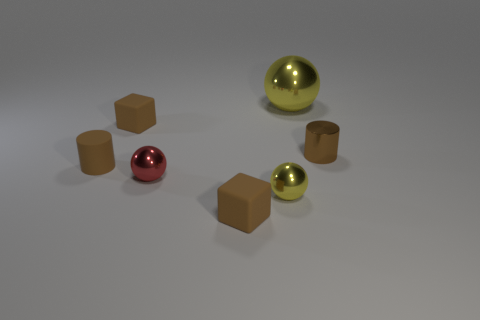Are there any tiny brown shiny objects of the same shape as the small red metallic thing?
Give a very brief answer. No. Does the large yellow shiny object have the same shape as the tiny red thing?
Ensure brevity in your answer.  Yes. What number of small objects are either matte cylinders or red balls?
Your answer should be compact. 2. Are there more tiny matte objects than cylinders?
Ensure brevity in your answer.  Yes. What size is the brown object that is made of the same material as the small red thing?
Your answer should be very brief. Small. Do the yellow ball in front of the red metal sphere and the cylinder that is in front of the small metal cylinder have the same size?
Offer a terse response. Yes. How many objects are either objects that are behind the red thing or big shiny things?
Provide a succinct answer. 4. Are there fewer tiny red shiny things than tiny brown matte cubes?
Your answer should be compact. Yes. What shape is the large yellow shiny thing behind the yellow metal object that is in front of the ball that is behind the red shiny thing?
Your answer should be very brief. Sphere. The other object that is the same color as the big shiny thing is what shape?
Your response must be concise. Sphere. 